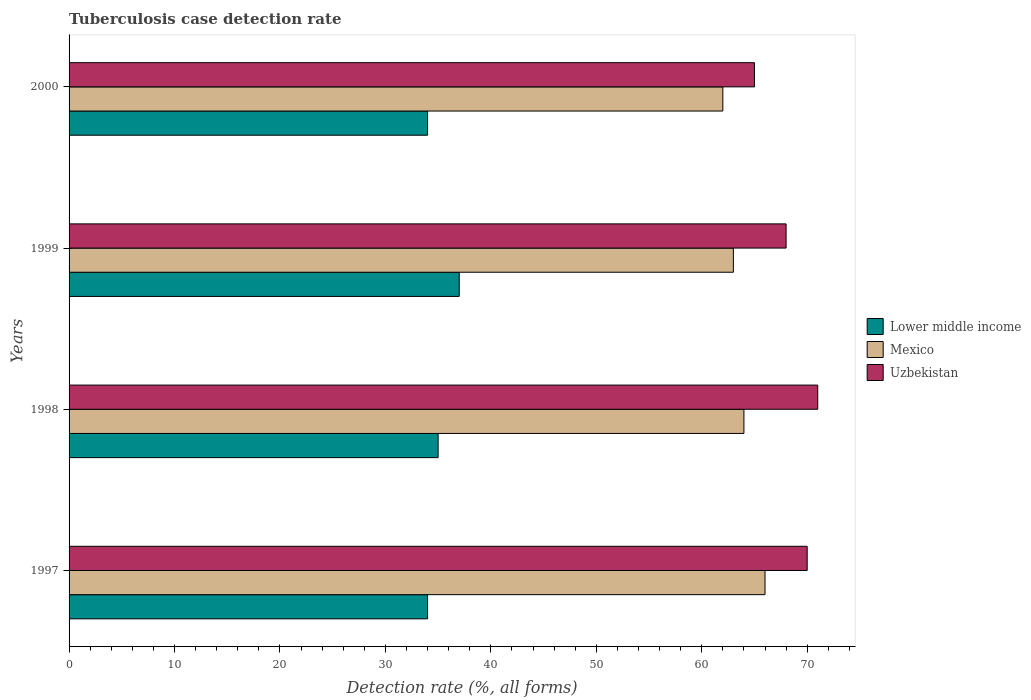Are the number of bars per tick equal to the number of legend labels?
Give a very brief answer. Yes. What is the label of the 3rd group of bars from the top?
Provide a short and direct response. 1998. In how many cases, is the number of bars for a given year not equal to the number of legend labels?
Provide a short and direct response. 0. What is the tuberculosis case detection rate in in Lower middle income in 1999?
Your answer should be compact. 37. Across all years, what is the minimum tuberculosis case detection rate in in Lower middle income?
Your answer should be very brief. 34. In which year was the tuberculosis case detection rate in in Uzbekistan maximum?
Provide a succinct answer. 1998. In which year was the tuberculosis case detection rate in in Mexico minimum?
Provide a succinct answer. 2000. What is the total tuberculosis case detection rate in in Uzbekistan in the graph?
Keep it short and to the point. 274. What is the difference between the tuberculosis case detection rate in in Lower middle income in 1998 and that in 2000?
Make the answer very short. 1. What is the difference between the tuberculosis case detection rate in in Mexico in 2000 and the tuberculosis case detection rate in in Uzbekistan in 1998?
Ensure brevity in your answer.  -9. What is the average tuberculosis case detection rate in in Mexico per year?
Your answer should be compact. 63.75. In the year 2000, what is the difference between the tuberculosis case detection rate in in Mexico and tuberculosis case detection rate in in Uzbekistan?
Make the answer very short. -3. In how many years, is the tuberculosis case detection rate in in Mexico greater than 38 %?
Provide a short and direct response. 4. What is the ratio of the tuberculosis case detection rate in in Mexico in 1999 to that in 2000?
Your answer should be compact. 1.02. Is the tuberculosis case detection rate in in Lower middle income in 1998 less than that in 2000?
Give a very brief answer. No. What is the difference between the highest and the second highest tuberculosis case detection rate in in Lower middle income?
Your answer should be compact. 2. What is the difference between the highest and the lowest tuberculosis case detection rate in in Mexico?
Your response must be concise. 4. Is the sum of the tuberculosis case detection rate in in Lower middle income in 1998 and 2000 greater than the maximum tuberculosis case detection rate in in Mexico across all years?
Your answer should be very brief. Yes. What does the 2nd bar from the top in 1997 represents?
Offer a very short reply. Mexico. What does the 3rd bar from the bottom in 2000 represents?
Keep it short and to the point. Uzbekistan. Are all the bars in the graph horizontal?
Your answer should be very brief. Yes. What is the difference between two consecutive major ticks on the X-axis?
Offer a very short reply. 10. Are the values on the major ticks of X-axis written in scientific E-notation?
Provide a succinct answer. No. Does the graph contain any zero values?
Your answer should be compact. No. Where does the legend appear in the graph?
Make the answer very short. Center right. What is the title of the graph?
Your answer should be compact. Tuberculosis case detection rate. What is the label or title of the X-axis?
Provide a short and direct response. Detection rate (%, all forms). What is the Detection rate (%, all forms) in Uzbekistan in 1997?
Provide a succinct answer. 70. What is the Detection rate (%, all forms) in Lower middle income in 1998?
Give a very brief answer. 35. What is the Detection rate (%, all forms) in Uzbekistan in 1998?
Keep it short and to the point. 71. What is the Detection rate (%, all forms) in Lower middle income in 2000?
Keep it short and to the point. 34. What is the Detection rate (%, all forms) in Mexico in 2000?
Provide a succinct answer. 62. What is the Detection rate (%, all forms) in Uzbekistan in 2000?
Give a very brief answer. 65. Across all years, what is the maximum Detection rate (%, all forms) of Lower middle income?
Make the answer very short. 37. Across all years, what is the minimum Detection rate (%, all forms) in Lower middle income?
Make the answer very short. 34. Across all years, what is the minimum Detection rate (%, all forms) in Mexico?
Offer a terse response. 62. What is the total Detection rate (%, all forms) of Lower middle income in the graph?
Your answer should be compact. 140. What is the total Detection rate (%, all forms) in Mexico in the graph?
Your response must be concise. 255. What is the total Detection rate (%, all forms) of Uzbekistan in the graph?
Offer a terse response. 274. What is the difference between the Detection rate (%, all forms) in Mexico in 1997 and that in 1998?
Provide a short and direct response. 2. What is the difference between the Detection rate (%, all forms) of Mexico in 1997 and that in 1999?
Keep it short and to the point. 3. What is the difference between the Detection rate (%, all forms) of Uzbekistan in 1997 and that in 1999?
Ensure brevity in your answer.  2. What is the difference between the Detection rate (%, all forms) of Mexico in 1997 and that in 2000?
Give a very brief answer. 4. What is the difference between the Detection rate (%, all forms) of Lower middle income in 1998 and that in 2000?
Offer a very short reply. 1. What is the difference between the Detection rate (%, all forms) of Uzbekistan in 1998 and that in 2000?
Offer a very short reply. 6. What is the difference between the Detection rate (%, all forms) of Lower middle income in 1997 and the Detection rate (%, all forms) of Mexico in 1998?
Provide a short and direct response. -30. What is the difference between the Detection rate (%, all forms) of Lower middle income in 1997 and the Detection rate (%, all forms) of Uzbekistan in 1998?
Provide a short and direct response. -37. What is the difference between the Detection rate (%, all forms) in Mexico in 1997 and the Detection rate (%, all forms) in Uzbekistan in 1998?
Make the answer very short. -5. What is the difference between the Detection rate (%, all forms) of Lower middle income in 1997 and the Detection rate (%, all forms) of Uzbekistan in 1999?
Offer a very short reply. -34. What is the difference between the Detection rate (%, all forms) of Mexico in 1997 and the Detection rate (%, all forms) of Uzbekistan in 1999?
Your answer should be compact. -2. What is the difference between the Detection rate (%, all forms) of Lower middle income in 1997 and the Detection rate (%, all forms) of Uzbekistan in 2000?
Ensure brevity in your answer.  -31. What is the difference between the Detection rate (%, all forms) of Mexico in 1997 and the Detection rate (%, all forms) of Uzbekistan in 2000?
Ensure brevity in your answer.  1. What is the difference between the Detection rate (%, all forms) in Lower middle income in 1998 and the Detection rate (%, all forms) in Uzbekistan in 1999?
Make the answer very short. -33. What is the difference between the Detection rate (%, all forms) of Mexico in 1998 and the Detection rate (%, all forms) of Uzbekistan in 1999?
Your answer should be very brief. -4. What is the difference between the Detection rate (%, all forms) of Lower middle income in 1998 and the Detection rate (%, all forms) of Mexico in 2000?
Ensure brevity in your answer.  -27. What is the difference between the Detection rate (%, all forms) of Lower middle income in 1998 and the Detection rate (%, all forms) of Uzbekistan in 2000?
Your response must be concise. -30. What is the difference between the Detection rate (%, all forms) in Lower middle income in 1999 and the Detection rate (%, all forms) in Mexico in 2000?
Keep it short and to the point. -25. What is the difference between the Detection rate (%, all forms) of Lower middle income in 1999 and the Detection rate (%, all forms) of Uzbekistan in 2000?
Provide a succinct answer. -28. What is the average Detection rate (%, all forms) of Lower middle income per year?
Provide a succinct answer. 35. What is the average Detection rate (%, all forms) in Mexico per year?
Provide a short and direct response. 63.75. What is the average Detection rate (%, all forms) in Uzbekistan per year?
Provide a succinct answer. 68.5. In the year 1997, what is the difference between the Detection rate (%, all forms) in Lower middle income and Detection rate (%, all forms) in Mexico?
Keep it short and to the point. -32. In the year 1997, what is the difference between the Detection rate (%, all forms) in Lower middle income and Detection rate (%, all forms) in Uzbekistan?
Offer a very short reply. -36. In the year 1998, what is the difference between the Detection rate (%, all forms) in Lower middle income and Detection rate (%, all forms) in Uzbekistan?
Your response must be concise. -36. In the year 1999, what is the difference between the Detection rate (%, all forms) of Lower middle income and Detection rate (%, all forms) of Uzbekistan?
Your response must be concise. -31. In the year 1999, what is the difference between the Detection rate (%, all forms) of Mexico and Detection rate (%, all forms) of Uzbekistan?
Keep it short and to the point. -5. In the year 2000, what is the difference between the Detection rate (%, all forms) in Lower middle income and Detection rate (%, all forms) in Uzbekistan?
Give a very brief answer. -31. What is the ratio of the Detection rate (%, all forms) in Lower middle income in 1997 to that in 1998?
Ensure brevity in your answer.  0.97. What is the ratio of the Detection rate (%, all forms) in Mexico in 1997 to that in 1998?
Keep it short and to the point. 1.03. What is the ratio of the Detection rate (%, all forms) in Uzbekistan in 1997 to that in 1998?
Ensure brevity in your answer.  0.99. What is the ratio of the Detection rate (%, all forms) in Lower middle income in 1997 to that in 1999?
Your answer should be compact. 0.92. What is the ratio of the Detection rate (%, all forms) in Mexico in 1997 to that in 1999?
Offer a terse response. 1.05. What is the ratio of the Detection rate (%, all forms) in Uzbekistan in 1997 to that in 1999?
Offer a very short reply. 1.03. What is the ratio of the Detection rate (%, all forms) in Mexico in 1997 to that in 2000?
Ensure brevity in your answer.  1.06. What is the ratio of the Detection rate (%, all forms) in Uzbekistan in 1997 to that in 2000?
Ensure brevity in your answer.  1.08. What is the ratio of the Detection rate (%, all forms) in Lower middle income in 1998 to that in 1999?
Your response must be concise. 0.95. What is the ratio of the Detection rate (%, all forms) in Mexico in 1998 to that in 1999?
Your answer should be compact. 1.02. What is the ratio of the Detection rate (%, all forms) in Uzbekistan in 1998 to that in 1999?
Keep it short and to the point. 1.04. What is the ratio of the Detection rate (%, all forms) in Lower middle income in 1998 to that in 2000?
Provide a short and direct response. 1.03. What is the ratio of the Detection rate (%, all forms) in Mexico in 1998 to that in 2000?
Your answer should be very brief. 1.03. What is the ratio of the Detection rate (%, all forms) in Uzbekistan in 1998 to that in 2000?
Your response must be concise. 1.09. What is the ratio of the Detection rate (%, all forms) of Lower middle income in 1999 to that in 2000?
Offer a terse response. 1.09. What is the ratio of the Detection rate (%, all forms) of Mexico in 1999 to that in 2000?
Your answer should be very brief. 1.02. What is the ratio of the Detection rate (%, all forms) in Uzbekistan in 1999 to that in 2000?
Make the answer very short. 1.05. What is the difference between the highest and the second highest Detection rate (%, all forms) of Lower middle income?
Ensure brevity in your answer.  2. What is the difference between the highest and the second highest Detection rate (%, all forms) in Mexico?
Offer a very short reply. 2. What is the difference between the highest and the second highest Detection rate (%, all forms) in Uzbekistan?
Ensure brevity in your answer.  1. What is the difference between the highest and the lowest Detection rate (%, all forms) of Mexico?
Provide a succinct answer. 4. 